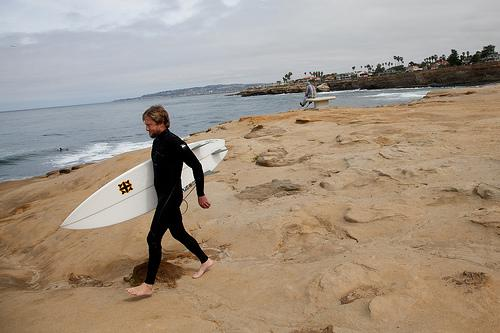Question: what is the man holding?
Choices:
A. A dog.
B. A child.
C. Surfboard.
D. A book.
Answer with the letter. Answer: C Question: what type of trees are in the background?
Choices:
A. Oak.
B. Palm trees.
C. Maple.
D. Pine.
Answer with the letter. Answer: B Question: where was this photo taken?
Choices:
A. In a bedroom.
B. In a field.
C. Beach.
D. In the woods.
Answer with the letter. Answer: C Question: what color is the man's wetsuit?
Choices:
A. Blue.
B. Orange.
C. Black.
D. Green.
Answer with the letter. Answer: C Question: what arm is holding the surfboard?
Choices:
A. Left.
B. Both arms.
C. Neither.
D. Right.
Answer with the letter. Answer: D Question: why is he wearing a wet suit?
Choices:
A. To stay warm.
B. To protect his skin.
C. For fashion.
D. The water is cold.
Answer with the letter. Answer: D 